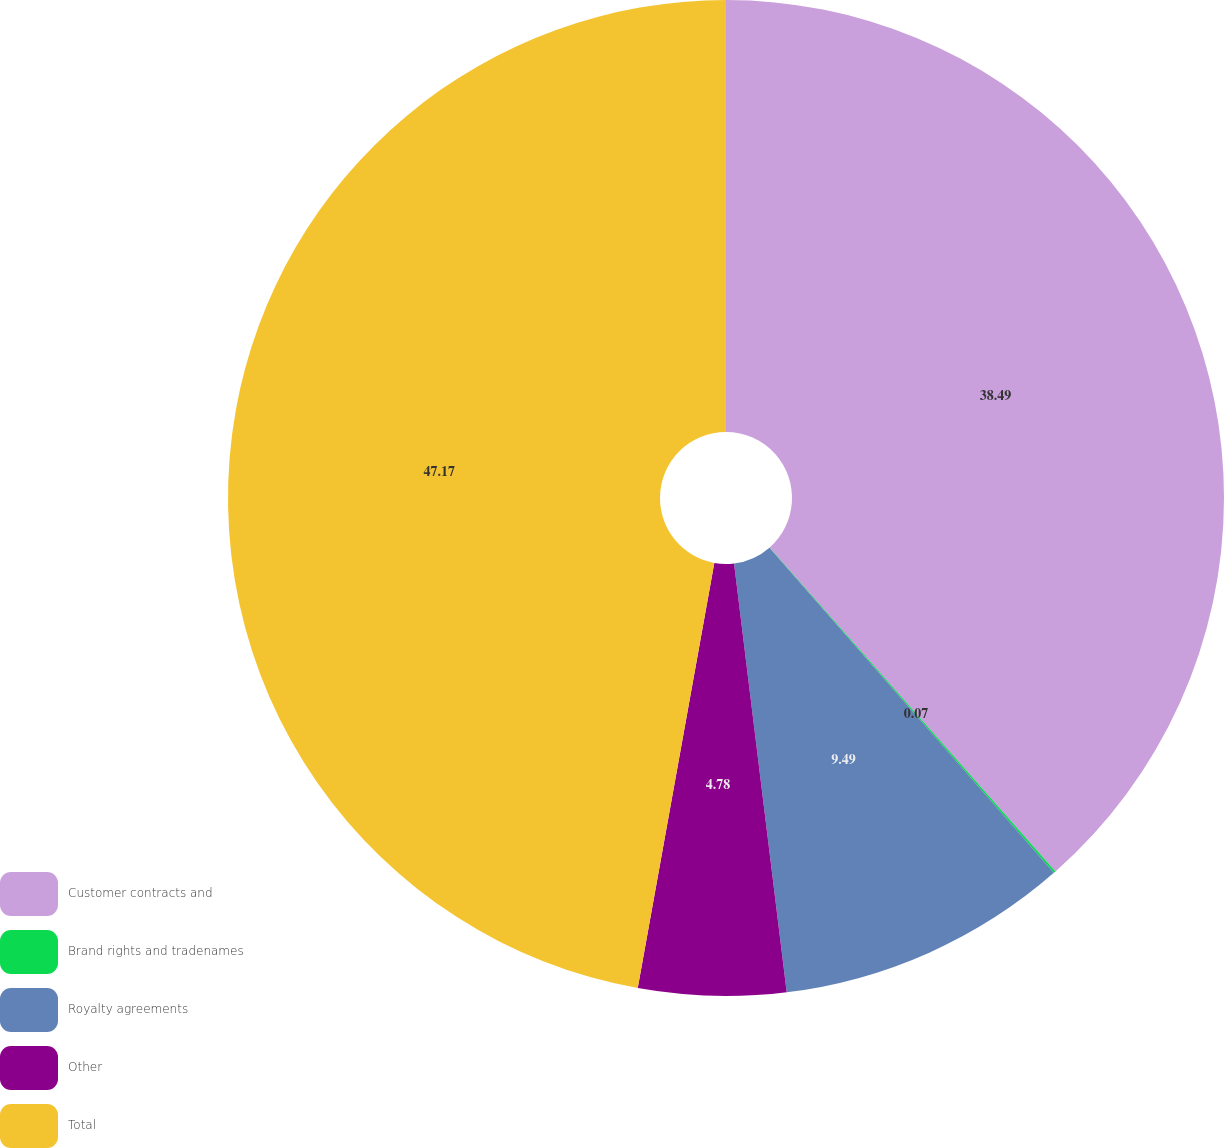Convert chart to OTSL. <chart><loc_0><loc_0><loc_500><loc_500><pie_chart><fcel>Customer contracts and<fcel>Brand rights and tradenames<fcel>Royalty agreements<fcel>Other<fcel>Total<nl><fcel>38.49%<fcel>0.07%<fcel>9.49%<fcel>4.78%<fcel>47.16%<nl></chart> 